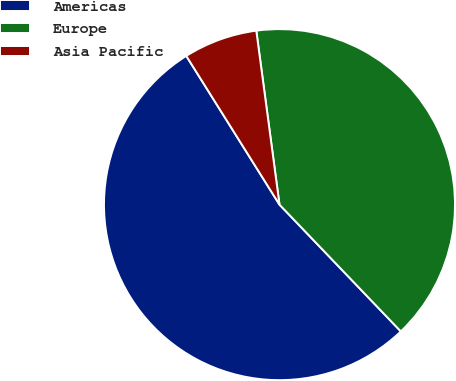<chart> <loc_0><loc_0><loc_500><loc_500><pie_chart><fcel>Americas<fcel>Europe<fcel>Asia Pacific<nl><fcel>53.24%<fcel>39.96%<fcel>6.8%<nl></chart> 